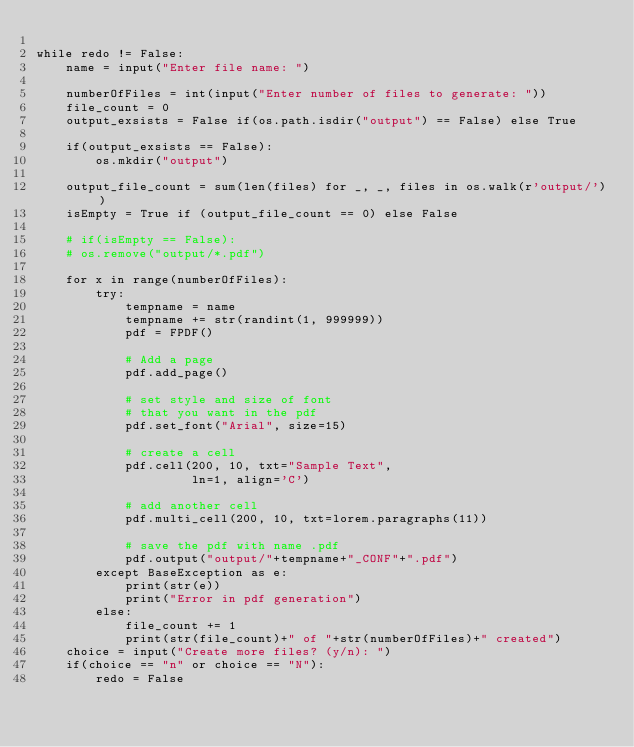<code> <loc_0><loc_0><loc_500><loc_500><_Python_>
while redo != False:
    name = input("Enter file name: ")

    numberOfFiles = int(input("Enter number of files to generate: "))
    file_count = 0
    output_exsists = False if(os.path.isdir("output") == False) else True

    if(output_exsists == False):
        os.mkdir("output")

    output_file_count = sum(len(files) for _, _, files in os.walk(r'output/'))
    isEmpty = True if (output_file_count == 0) else False

    # if(isEmpty == False):
    # os.remove("output/*.pdf")

    for x in range(numberOfFiles):
        try:
            tempname = name
            tempname += str(randint(1, 999999))
            pdf = FPDF()

            # Add a page
            pdf.add_page()

            # set style and size of font
            # that you want in the pdf
            pdf.set_font("Arial", size=15)

            # create a cell
            pdf.cell(200, 10, txt="Sample Text",
                     ln=1, align='C')

            # add another cell
            pdf.multi_cell(200, 10, txt=lorem.paragraphs(11))

            # save the pdf with name .pdf
            pdf.output("output/"+tempname+"_CONF"+".pdf")
        except BaseException as e:
            print(str(e))
            print("Error in pdf generation")
        else:
            file_count += 1
            print(str(file_count)+" of "+str(numberOfFiles)+" created")
    choice = input("Create more files? (y/n): ")
    if(choice == "n" or choice == "N"):
        redo = False
</code> 